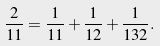Convert formula to latex. <formula><loc_0><loc_0><loc_500><loc_500>\frac { 2 } { 1 1 } = \frac { 1 } { 1 1 } + \frac { 1 } { 1 2 } + \frac { 1 } { 1 3 2 } .</formula> 